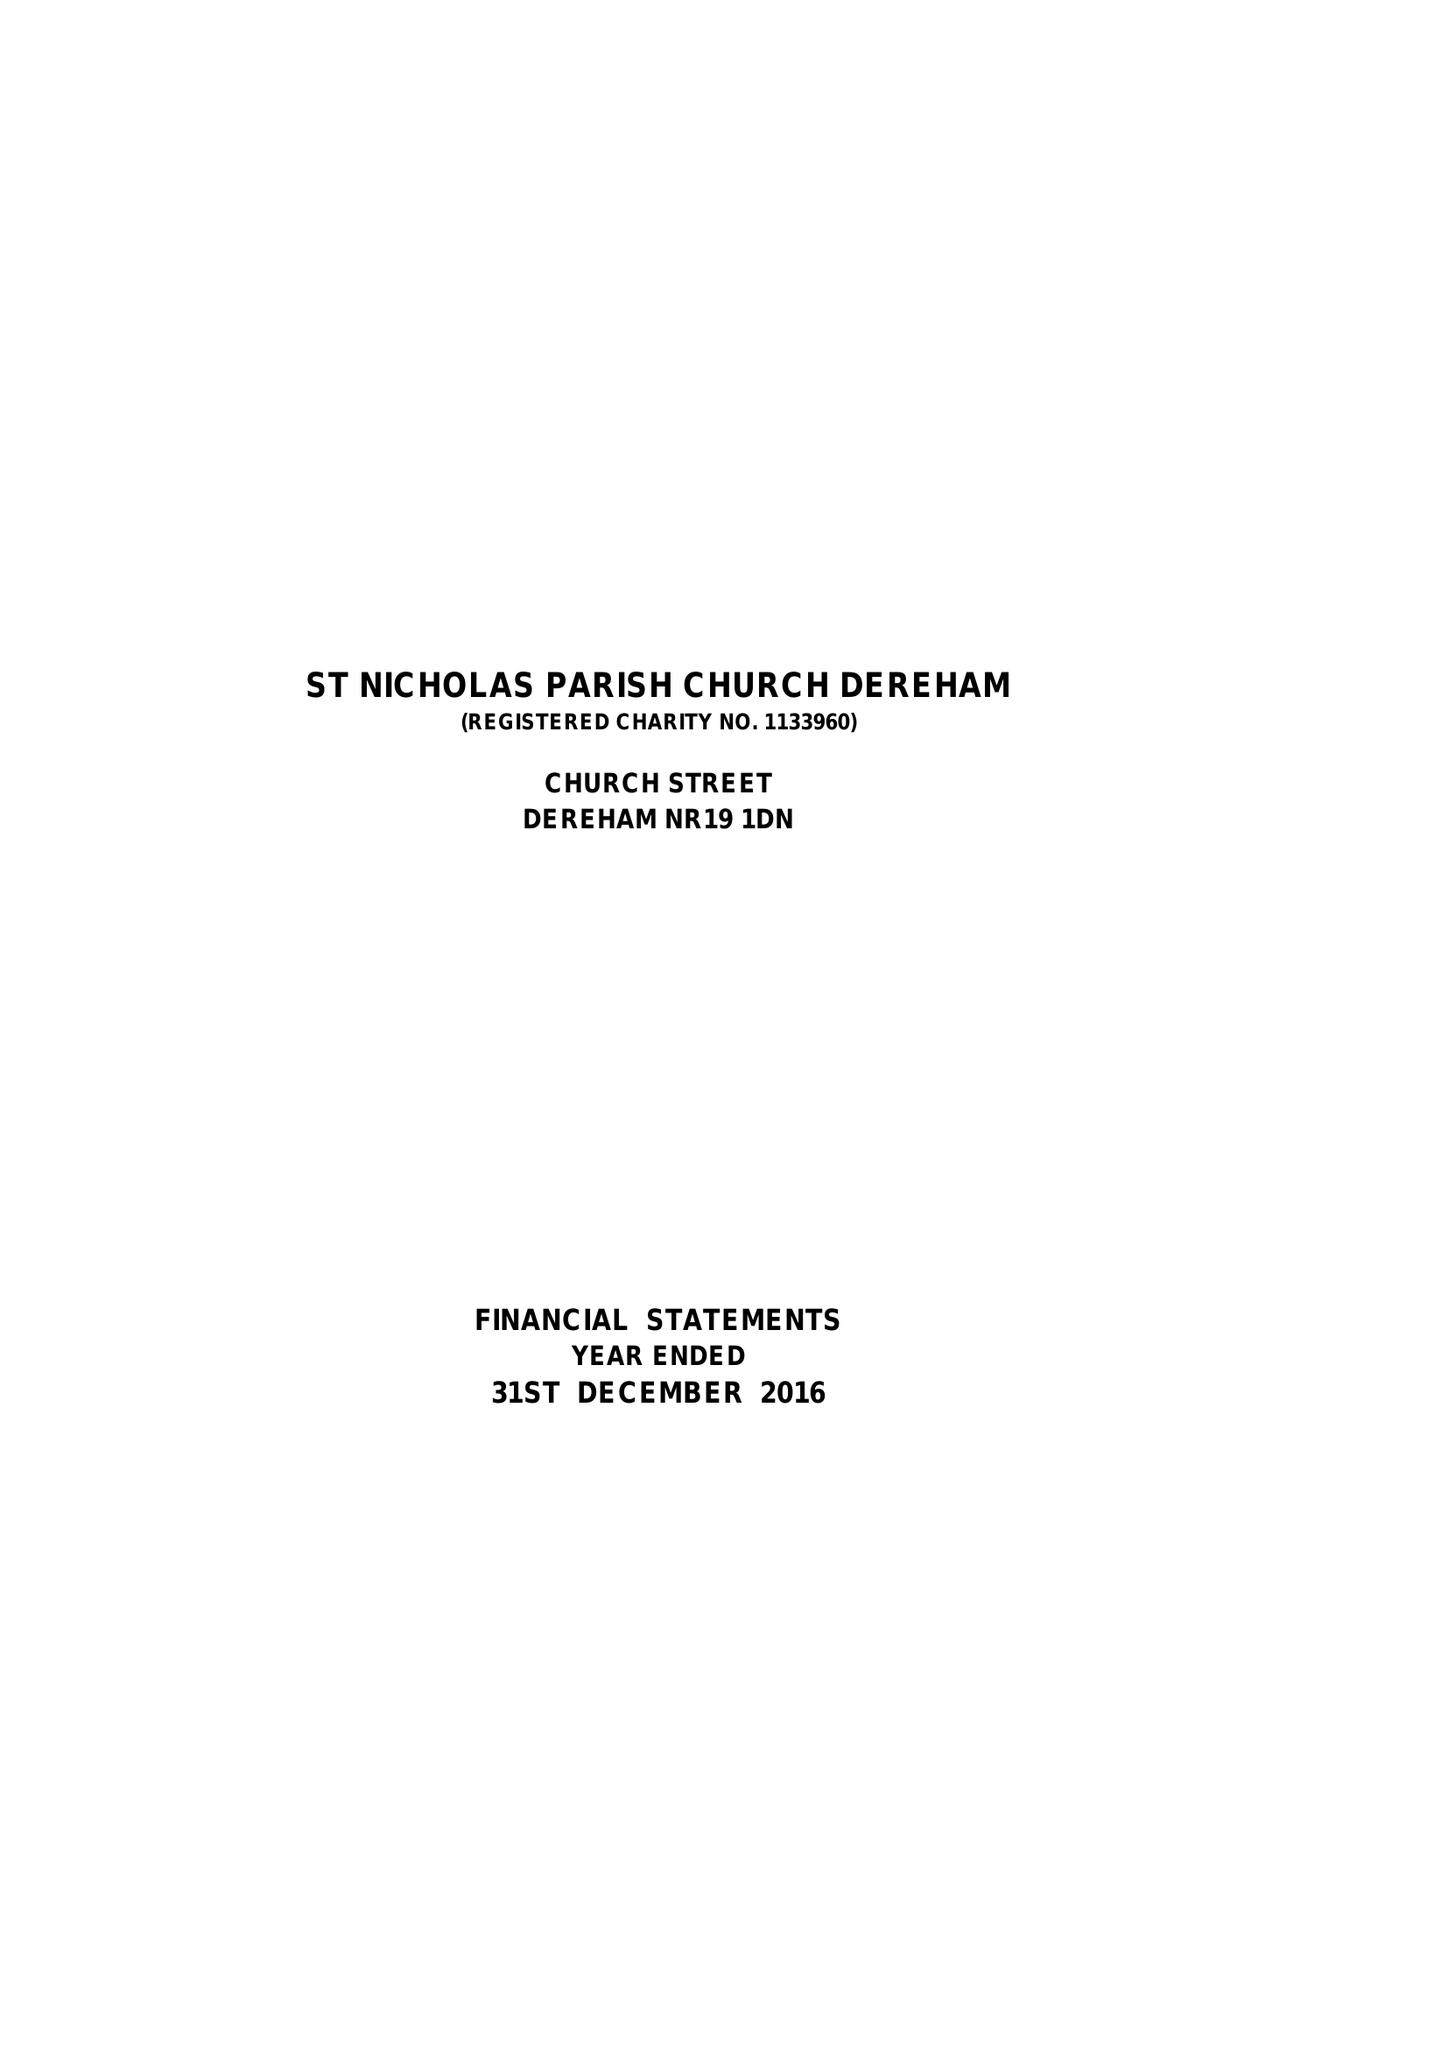What is the value for the report_date?
Answer the question using a single word or phrase. 2016-12-31 